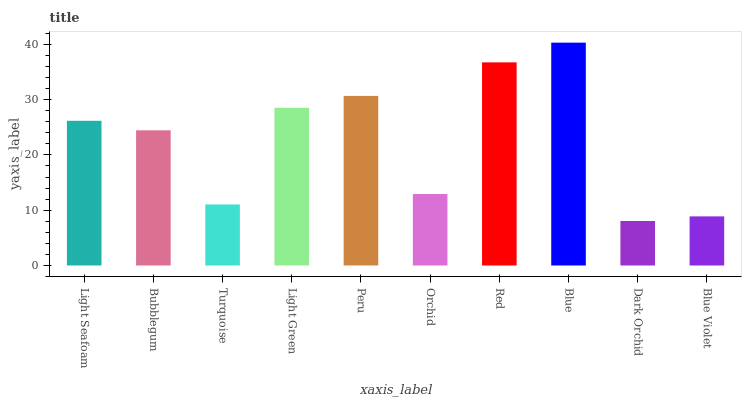Is Dark Orchid the minimum?
Answer yes or no. Yes. Is Blue the maximum?
Answer yes or no. Yes. Is Bubblegum the minimum?
Answer yes or no. No. Is Bubblegum the maximum?
Answer yes or no. No. Is Light Seafoam greater than Bubblegum?
Answer yes or no. Yes. Is Bubblegum less than Light Seafoam?
Answer yes or no. Yes. Is Bubblegum greater than Light Seafoam?
Answer yes or no. No. Is Light Seafoam less than Bubblegum?
Answer yes or no. No. Is Light Seafoam the high median?
Answer yes or no. Yes. Is Bubblegum the low median?
Answer yes or no. Yes. Is Blue the high median?
Answer yes or no. No. Is Blue Violet the low median?
Answer yes or no. No. 